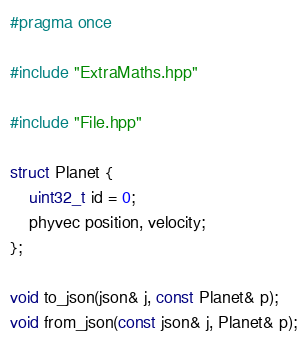Convert code to text. <code><loc_0><loc_0><loc_500><loc_500><_C++_>#pragma once

#include "ExtraMaths.hpp"

#include "File.hpp"

struct Planet {
	uint32_t id = 0;
	phyvec position, velocity;
};

void to_json(json& j, const Planet& p);
void from_json(const json& j, Planet& p);</code> 